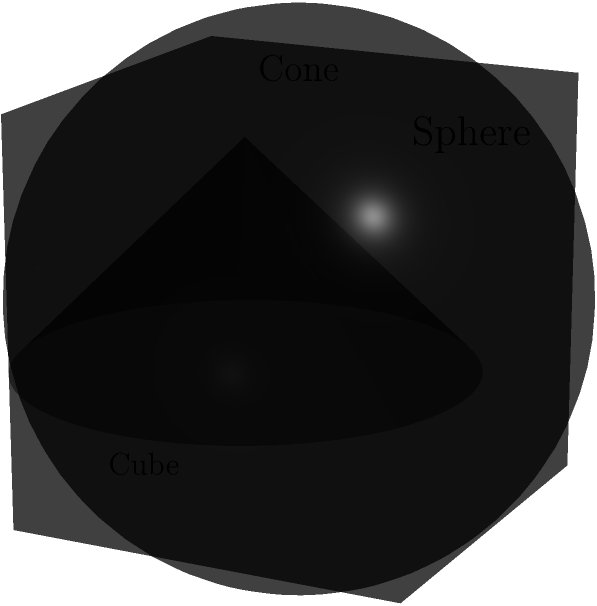In a therapeutic visualization exercise, you're presented with three geometric solids representing different aspects of your experiences: a unit cube symbolizing structure, a sphere of radius 0.7 centered at (0.5, 0.5, 0.5) representing wholeness, and a cone with base radius 0.6 and height 0.6 centered at (0.2, 0.2, 0.2) symbolizing focus. What is the approximate volume of the region where all three solids intersect? To find the volume of the intersection, we'll follow these steps:

1) First, recognize that the intersection will be a complex shape, so we'll use an approximation method.

2) The cube has a volume of 1, the sphere has a volume of $\frac{4}{3}\pi(0.7)^3 \approx 1.44$, and the cone has a volume of $\frac{1}{3}\pi(0.6)^2(0.6) \approx 0.07$.

3) The intersection will be smaller than the smallest of these volumes (the cone).

4) Considering the positions of the solids:
   - The sphere is centered in the cube and occupies most of it.
   - The cone's base is near one corner of the cube and extends diagonally.
   - The intersection will be in the lower corner of the cube where the cone is positioned.

5) Estimating conservatively, the intersection might occupy about 1/4 to 1/3 of the cone's volume.

6) Therefore, a reasonable estimate for the volume of intersection would be:
   $\frac{1}{4} \times 0.07 \approx 0.0175$ to $\frac{1}{3} \times 0.07 \approx 0.023$

7) Taking the average of these estimates: $(0.0175 + 0.023) / 2 \approx 0.02$

This is a rough approximation, but it gives us a reasonable estimate of the intersection volume.
Answer: $\approx 0.02$ cubic units 